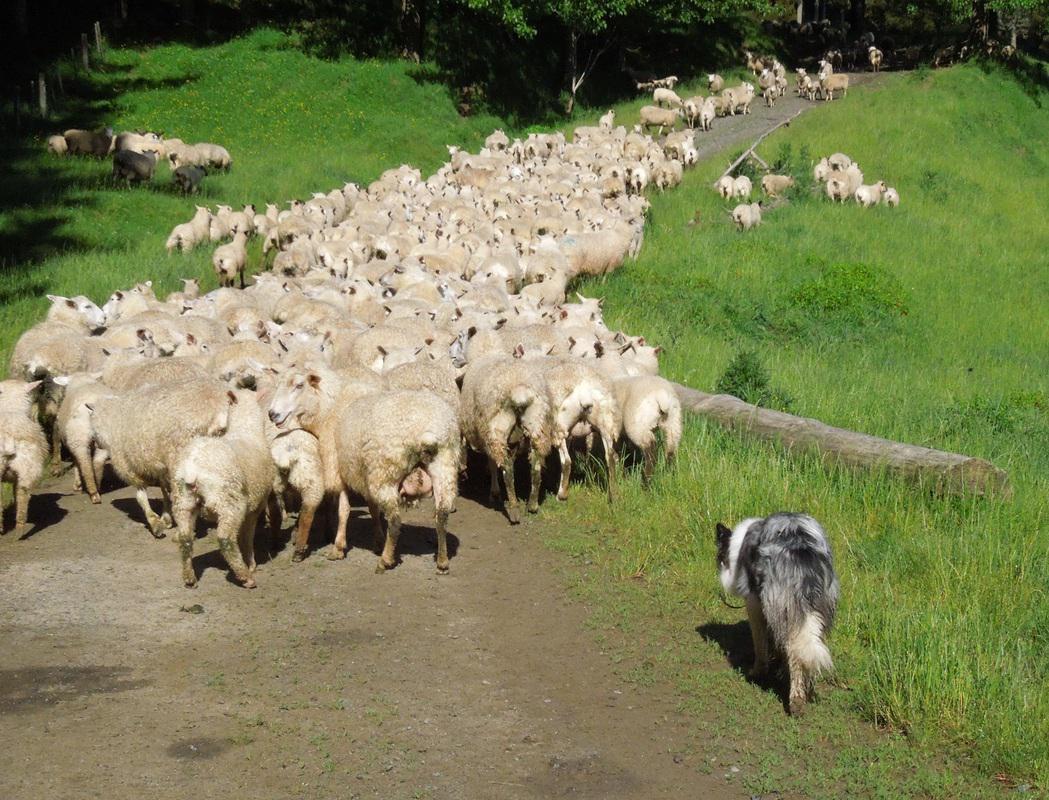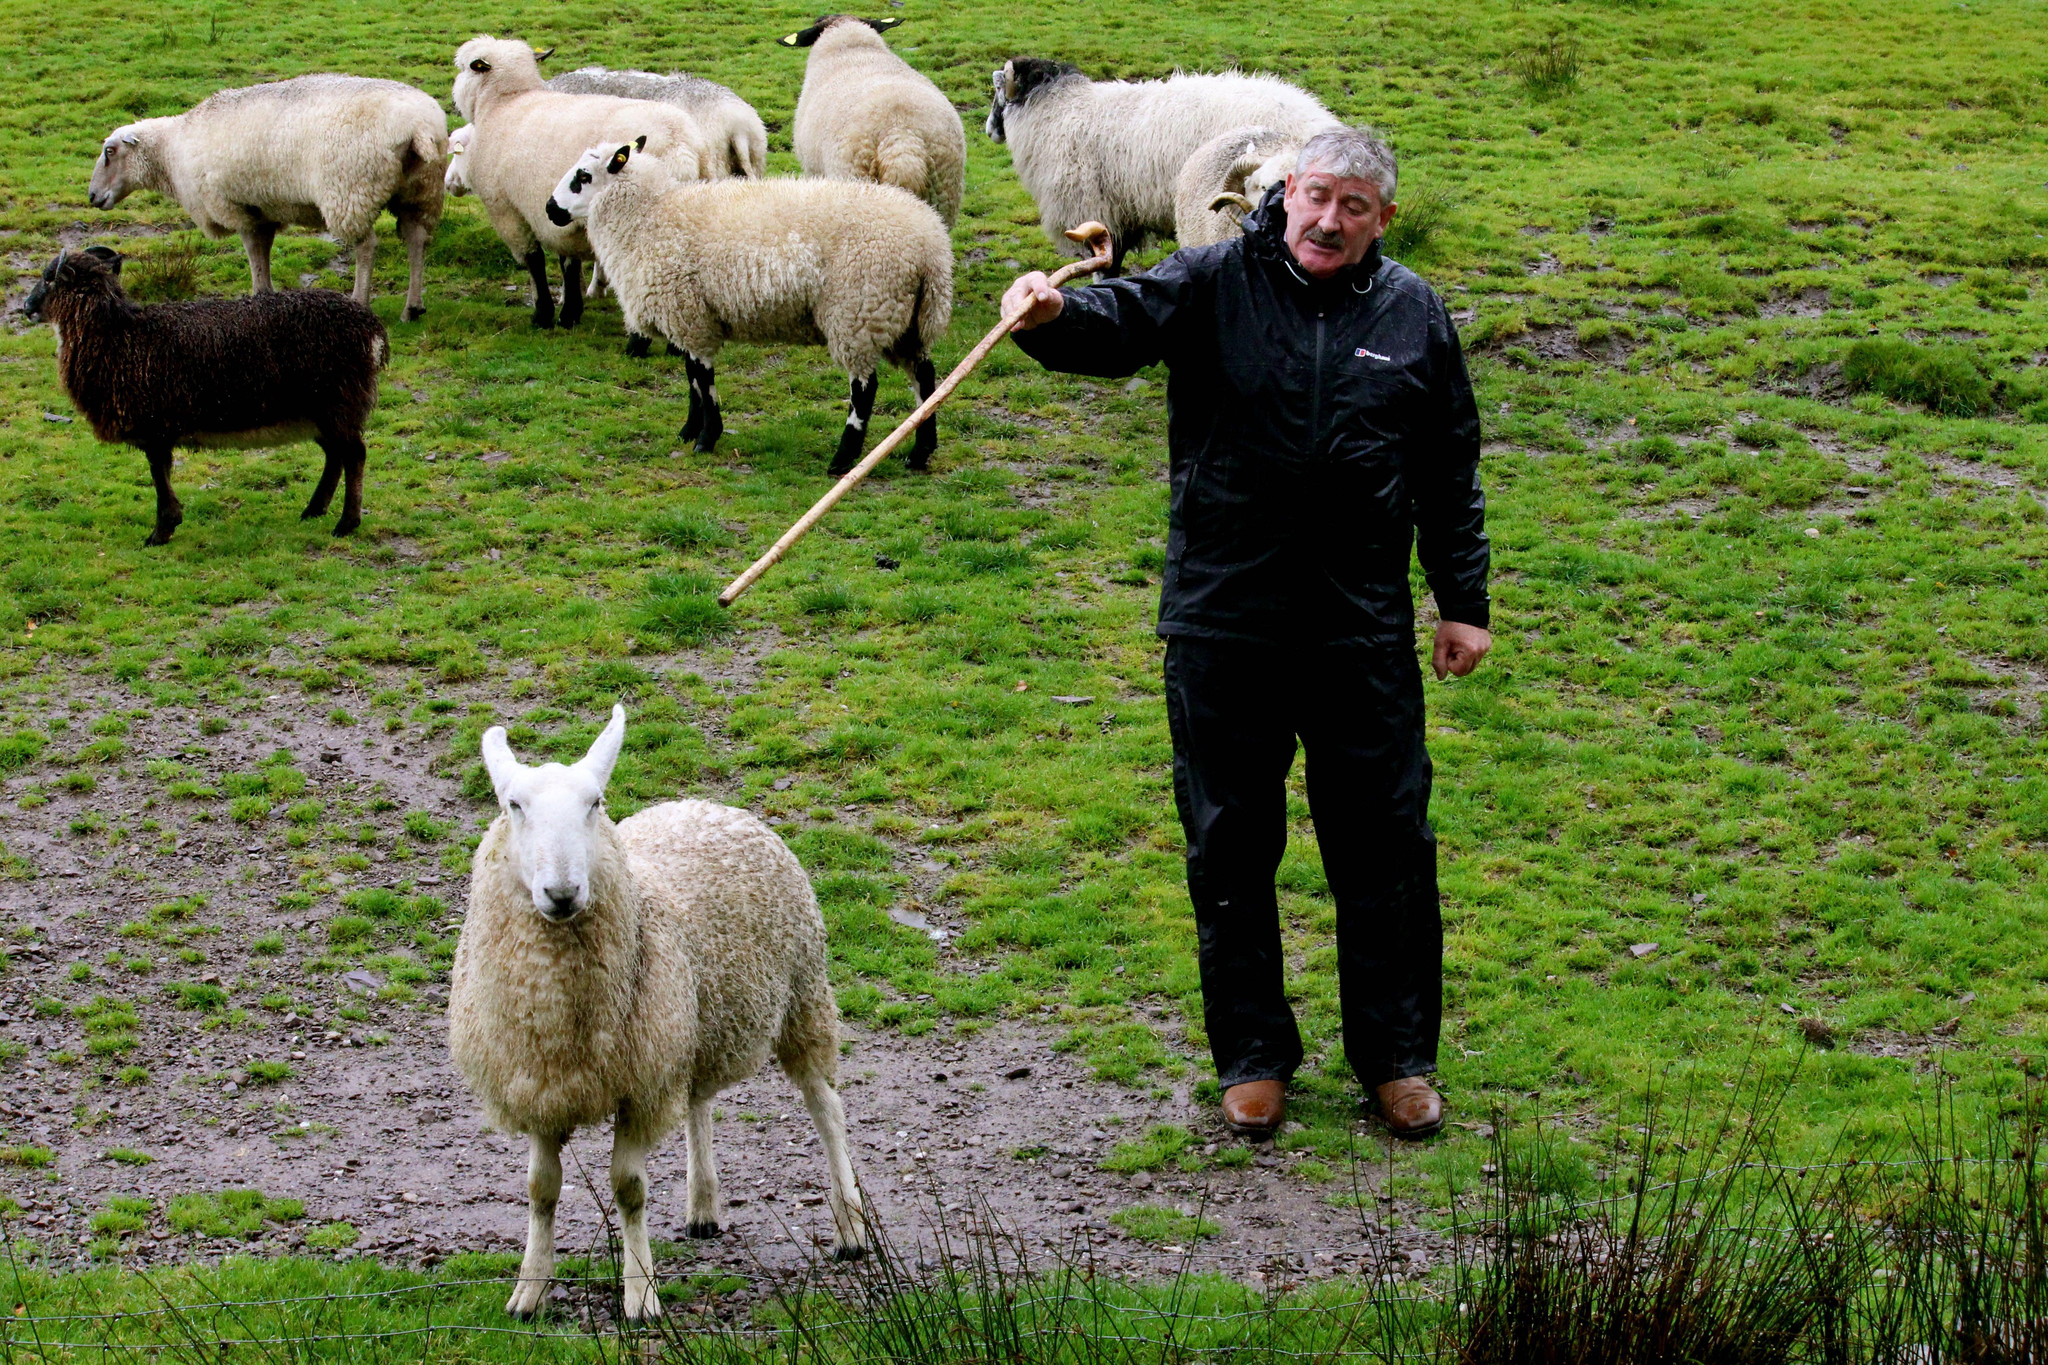The first image is the image on the left, the second image is the image on the right. Considering the images on both sides, is "A person is standing with the dog and sheep in one of the images." valid? Answer yes or no. Yes. The first image is the image on the left, the second image is the image on the right. Examine the images to the left and right. Is the description "An image shows a man standing and holding onto something useful for herding the sheep in the picture." accurate? Answer yes or no. Yes. 